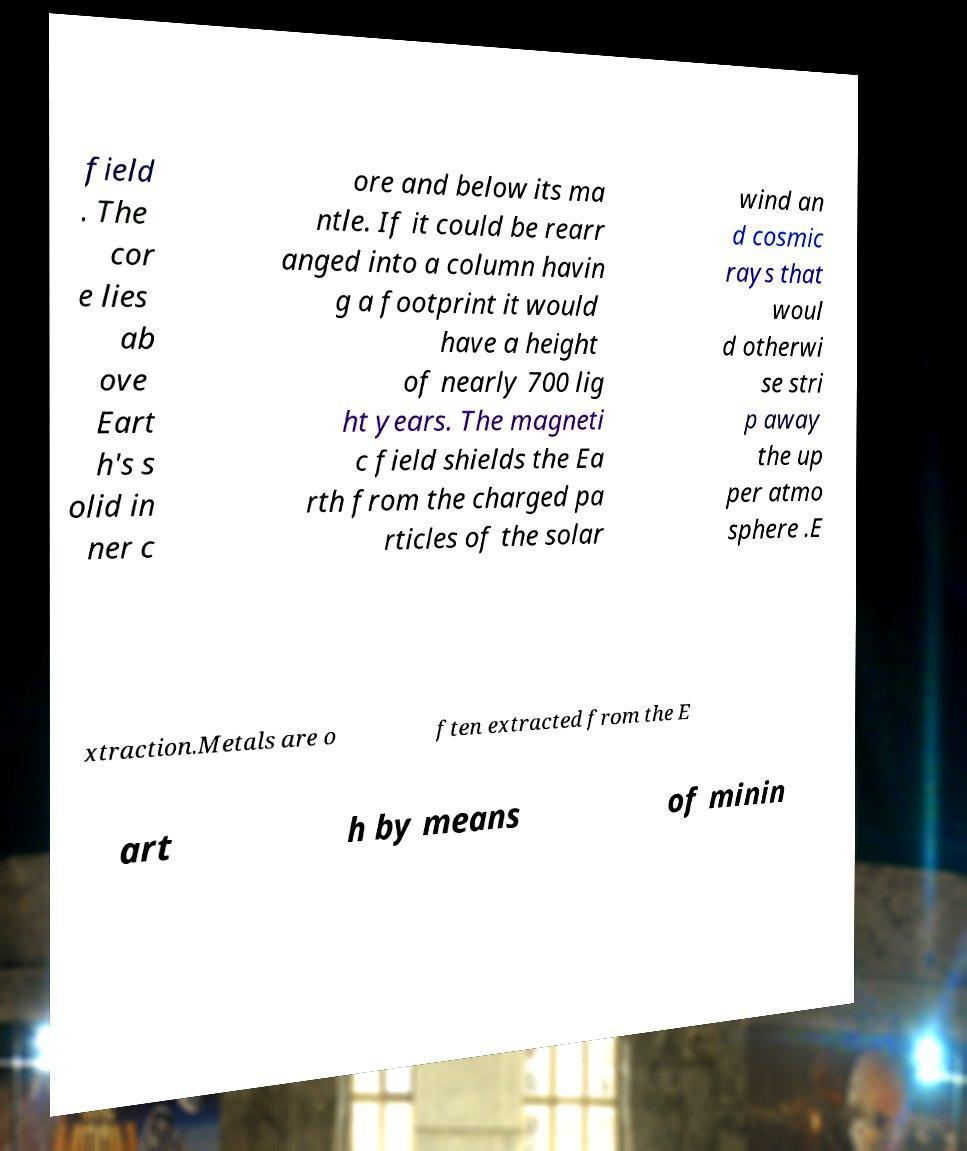Could you assist in decoding the text presented in this image and type it out clearly? field . The cor e lies ab ove Eart h's s olid in ner c ore and below its ma ntle. If it could be rearr anged into a column havin g a footprint it would have a height of nearly 700 lig ht years. The magneti c field shields the Ea rth from the charged pa rticles of the solar wind an d cosmic rays that woul d otherwi se stri p away the up per atmo sphere .E xtraction.Metals are o ften extracted from the E art h by means of minin 